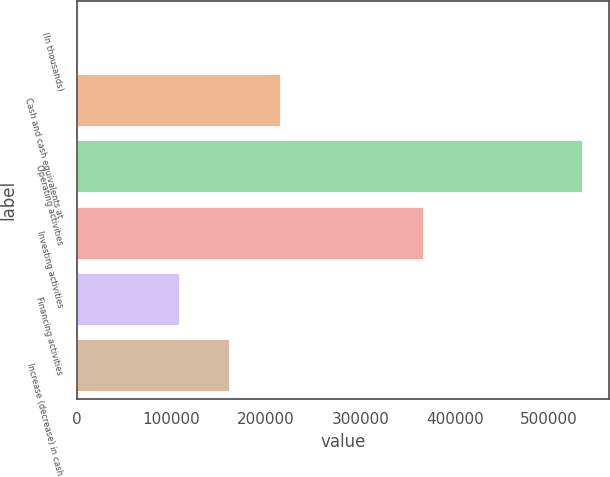Convert chart. <chart><loc_0><loc_0><loc_500><loc_500><bar_chart><fcel>(In thousands)<fcel>Cash and cash equivalents at<fcel>Operating activities<fcel>Investing activities<fcel>Financing activities<fcel>Increase (decrease) in cash<nl><fcel>2017<fcel>215728<fcel>536294<fcel>367746<fcel>108872<fcel>162300<nl></chart> 